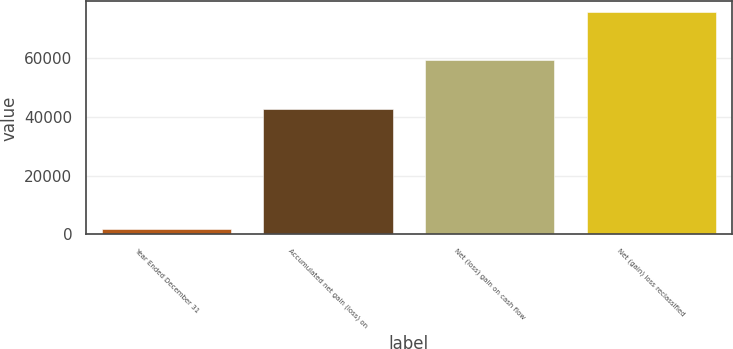Convert chart. <chart><loc_0><loc_0><loc_500><loc_500><bar_chart><fcel>Year Ended December 31<fcel>Accumulated net gain (loss) on<fcel>Net (loss) gain on cash flow<fcel>Net (gain) loss reclassified<nl><fcel>2010<fcel>42848<fcel>59249.8<fcel>75651.6<nl></chart> 